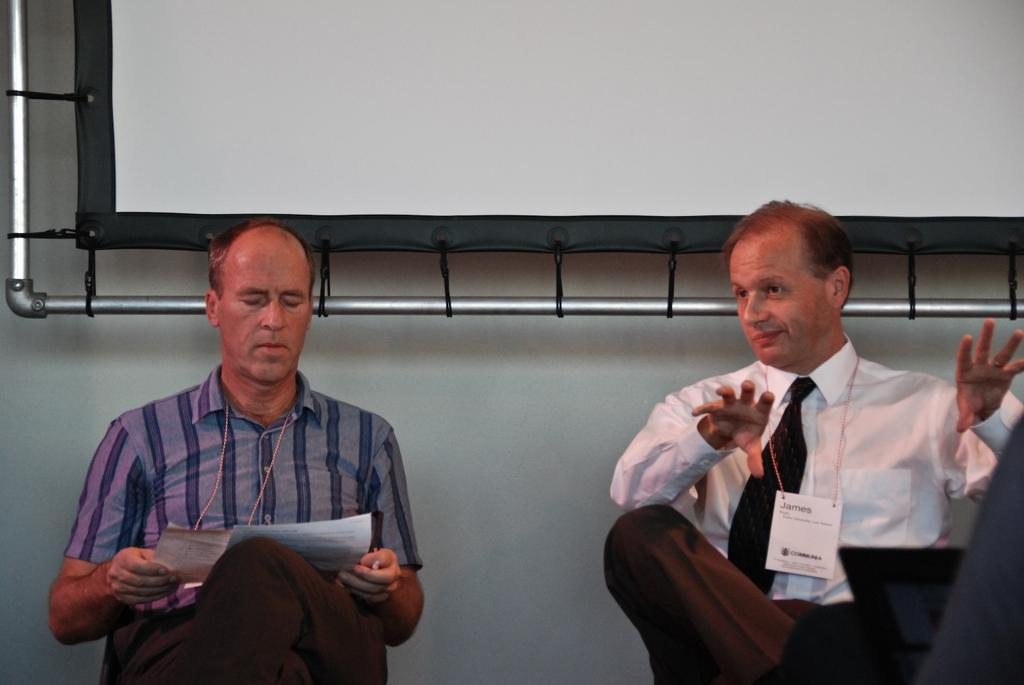How many people are in the image? There are two persons in the image. What are the people wearing? Both persons are wearing tags. What is one person holding? One person is holding papers. What can be seen in the background of the image? There is a board and a wall visible in the background. How does the snail feel about the comparison between the two persons in the image? There is no snail present in the image, so it is not possible to determine how a snail might feel about a comparison between the two persons. 